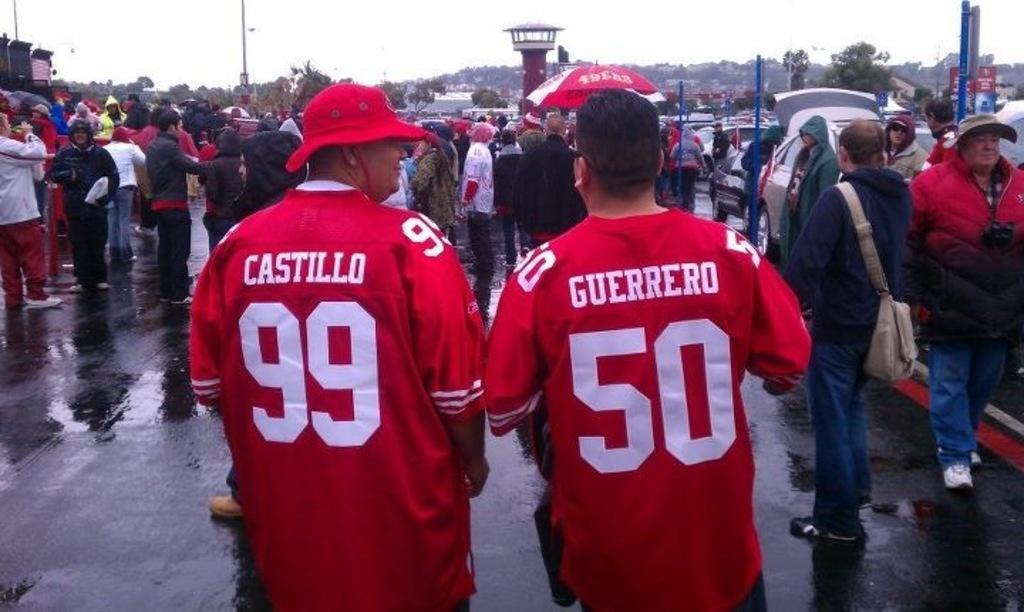<image>
Write a terse but informative summary of the picture. the number 50 is on the red shirt of the man outside 